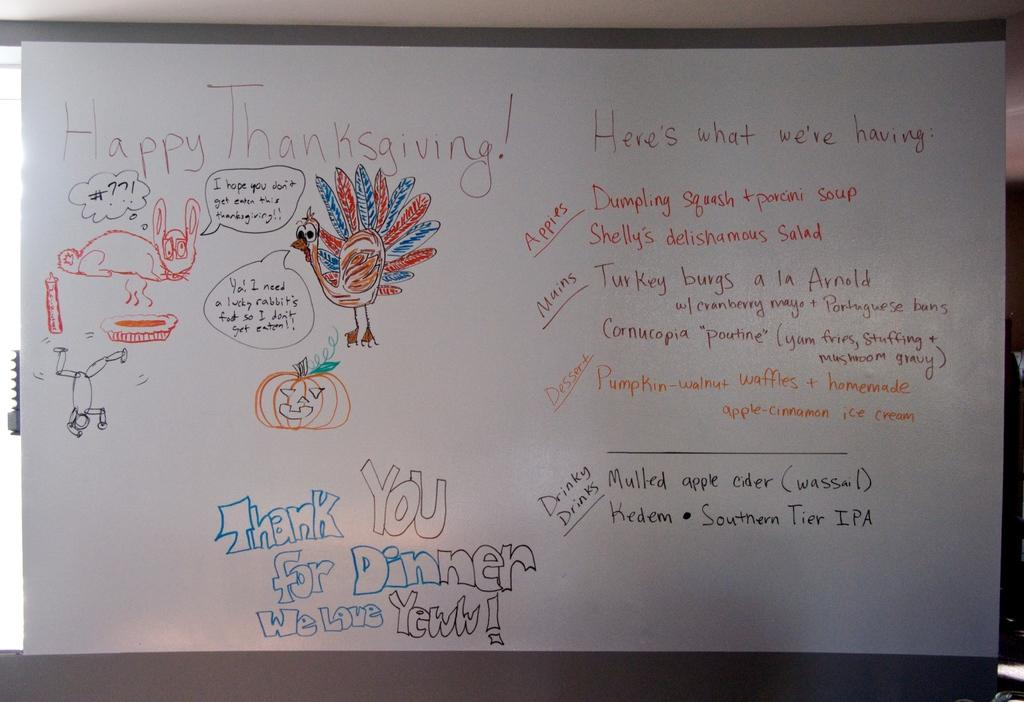<image>
Present a compact description of the photo's key features. A white board says the words "Happy Thanksgiving!" 